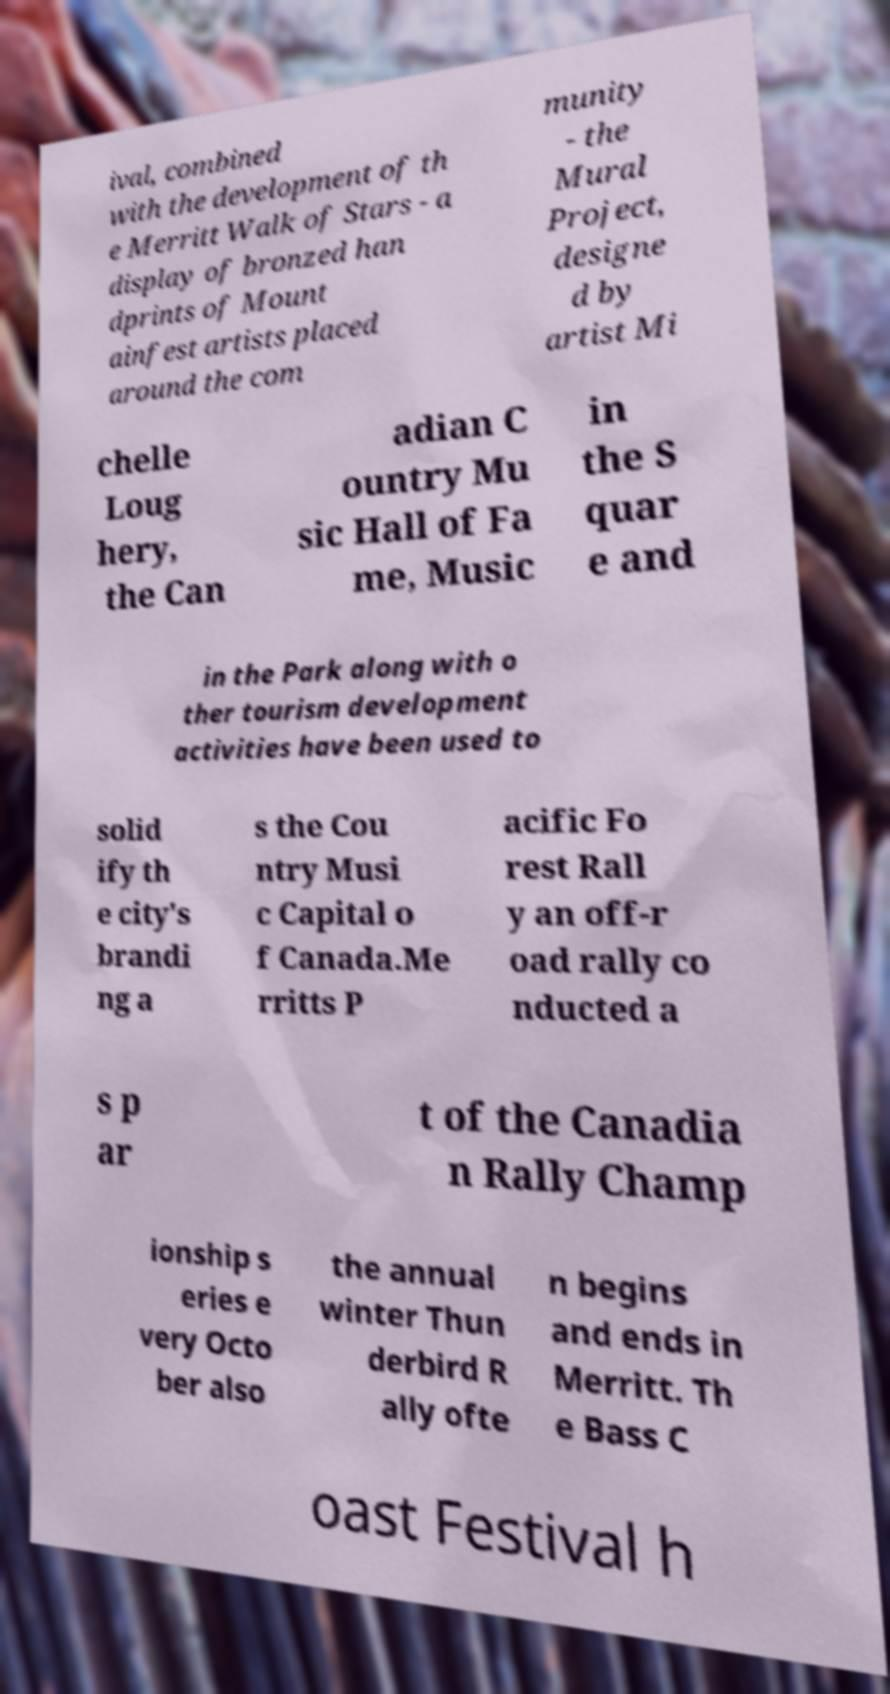Could you extract and type out the text from this image? ival, combined with the development of th e Merritt Walk of Stars - a display of bronzed han dprints of Mount ainfest artists placed around the com munity - the Mural Project, designe d by artist Mi chelle Loug hery, the Can adian C ountry Mu sic Hall of Fa me, Music in the S quar e and in the Park along with o ther tourism development activities have been used to solid ify th e city's brandi ng a s the Cou ntry Musi c Capital o f Canada.Me rritts P acific Fo rest Rall y an off-r oad rally co nducted a s p ar t of the Canadia n Rally Champ ionship s eries e very Octo ber also the annual winter Thun derbird R ally ofte n begins and ends in Merritt. Th e Bass C oast Festival h 